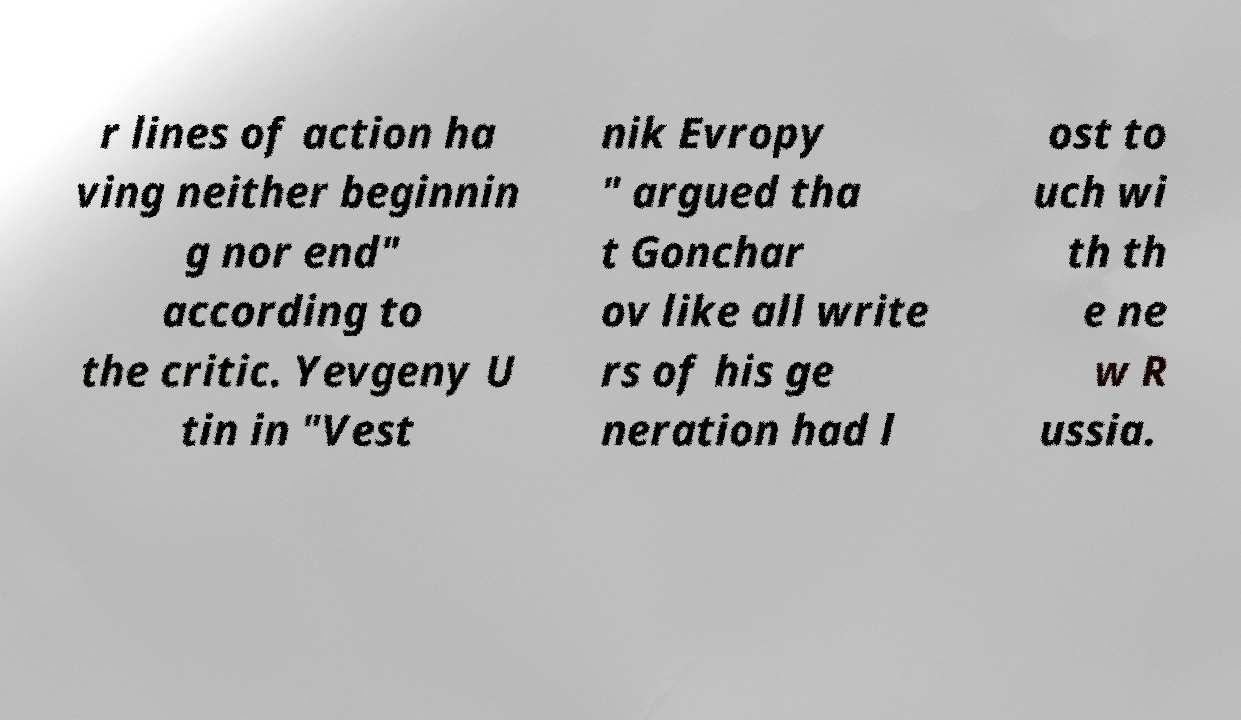Could you assist in decoding the text presented in this image and type it out clearly? r lines of action ha ving neither beginnin g nor end" according to the critic. Yevgeny U tin in "Vest nik Evropy " argued tha t Gonchar ov like all write rs of his ge neration had l ost to uch wi th th e ne w R ussia. 